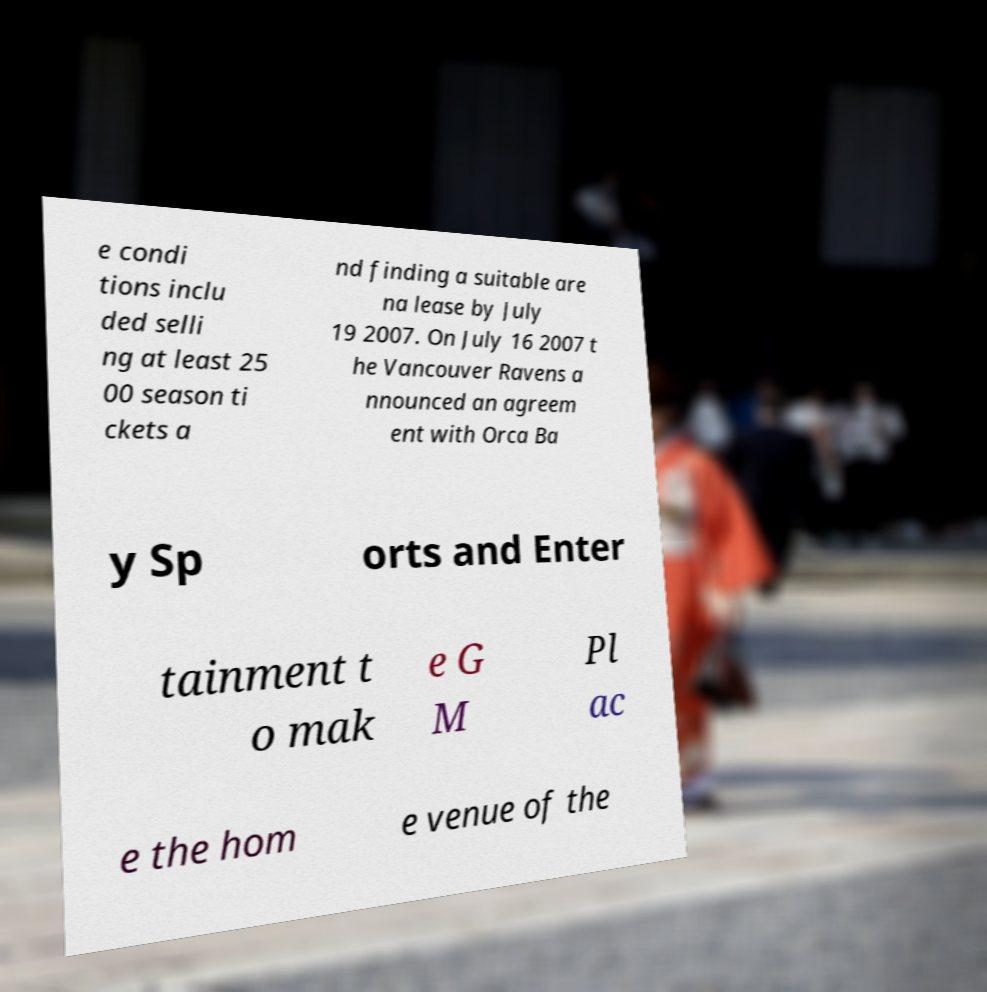Please identify and transcribe the text found in this image. e condi tions inclu ded selli ng at least 25 00 season ti ckets a nd finding a suitable are na lease by July 19 2007. On July 16 2007 t he Vancouver Ravens a nnounced an agreem ent with Orca Ba y Sp orts and Enter tainment t o mak e G M Pl ac e the hom e venue of the 